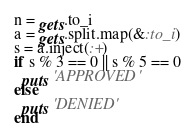<code> <loc_0><loc_0><loc_500><loc_500><_Ruby_>n = gets.to_i
a = gets.split.map(&:to_i)
s = a.inject(:+)
if s % 3 == 0 || s % 5 == 0
  puts 'APPROVED'
else
  puts 'DENIED'
end</code> 